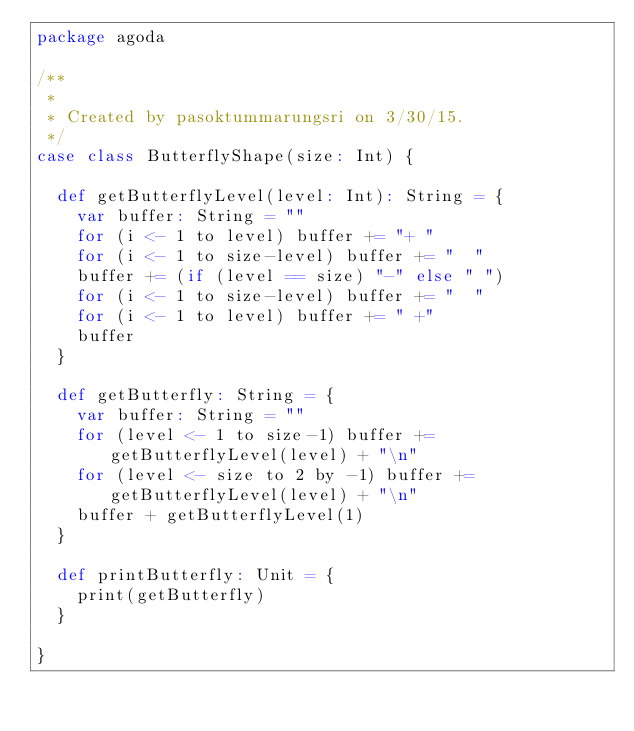Convert code to text. <code><loc_0><loc_0><loc_500><loc_500><_Scala_>package agoda

/**
 *
 * Created by pasoktummarungsri on 3/30/15.
 */
case class ButterflyShape(size: Int) {

  def getButterflyLevel(level: Int): String = {
    var buffer: String = ""
    for (i <- 1 to level) buffer += "+ "
    for (i <- 1 to size-level) buffer += "  "
    buffer += (if (level == size) "-" else " ")
    for (i <- 1 to size-level) buffer += "  "
    for (i <- 1 to level) buffer += " +"
    buffer
  }

  def getButterfly: String = {
    var buffer: String = ""
    for (level <- 1 to size-1) buffer += getButterflyLevel(level) + "\n"
    for (level <- size to 2 by -1) buffer += getButterflyLevel(level) + "\n"
    buffer + getButterflyLevel(1)
  }

  def printButterfly: Unit = {
    print(getButterfly)
  }

}
</code> 